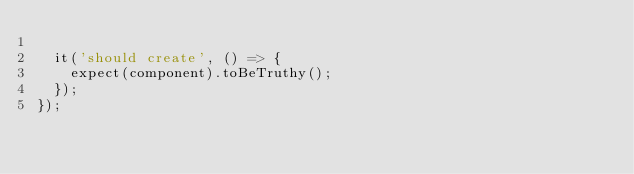Convert code to text. <code><loc_0><loc_0><loc_500><loc_500><_TypeScript_>
  it('should create', () => {
    expect(component).toBeTruthy();
  });
});
</code> 